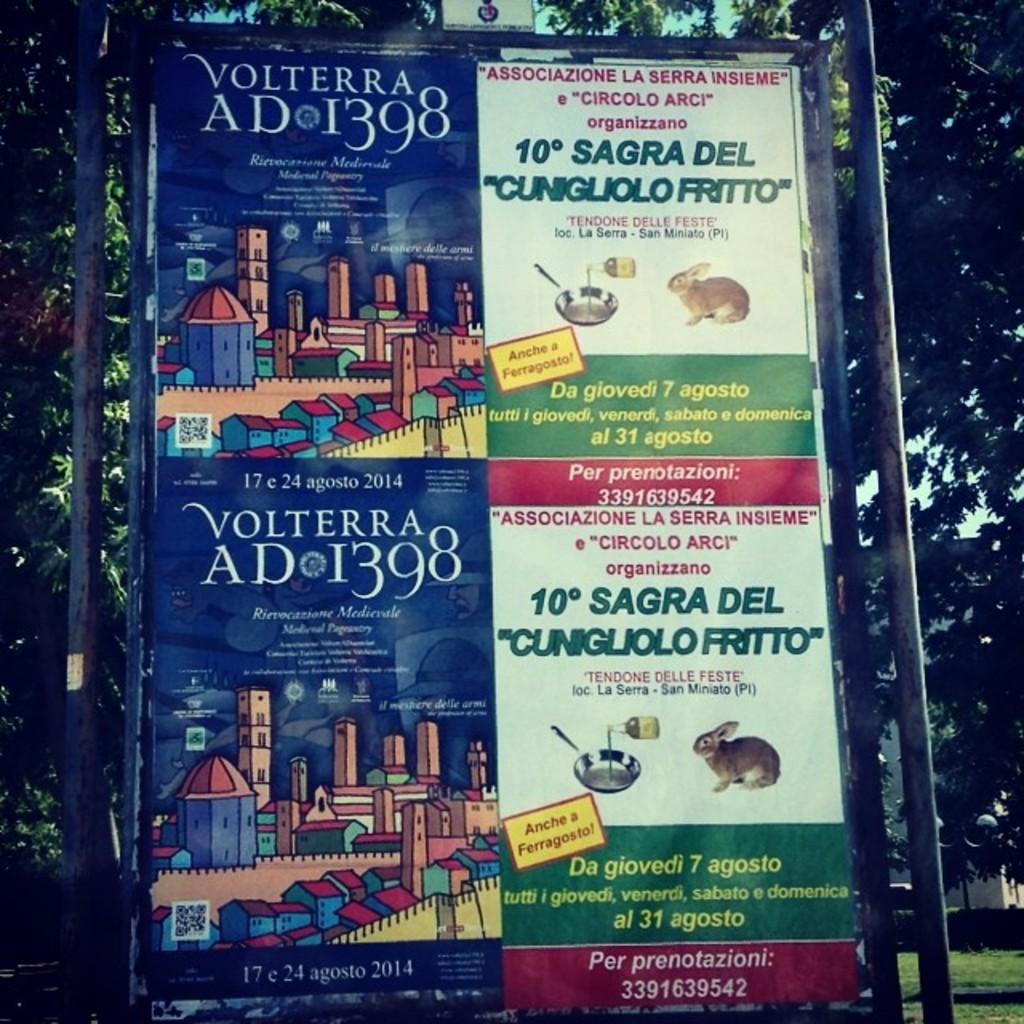What year ad is it?
Give a very brief answer. 1398. What month is the ad?
Your response must be concise. Agosto. 